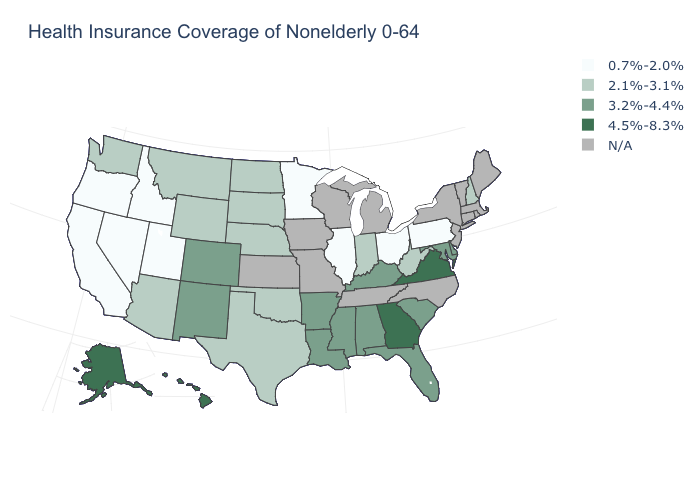Does the map have missing data?
Quick response, please. Yes. What is the value of New Hampshire?
Concise answer only. 2.1%-3.1%. What is the highest value in the USA?
Concise answer only. 4.5%-8.3%. Does Indiana have the highest value in the MidWest?
Write a very short answer. Yes. Name the states that have a value in the range 2.1%-3.1%?
Short answer required. Arizona, Indiana, Montana, Nebraska, New Hampshire, North Dakota, Oklahoma, South Dakota, Texas, Washington, West Virginia, Wyoming. Name the states that have a value in the range 4.5%-8.3%?
Give a very brief answer. Alaska, Georgia, Hawaii, Virginia. Among the states that border Colorado , does Arizona have the lowest value?
Keep it brief. No. What is the highest value in the South ?
Write a very short answer. 4.5%-8.3%. Name the states that have a value in the range 2.1%-3.1%?
Short answer required. Arizona, Indiana, Montana, Nebraska, New Hampshire, North Dakota, Oklahoma, South Dakota, Texas, Washington, West Virginia, Wyoming. Which states have the lowest value in the USA?
Keep it brief. California, Idaho, Illinois, Minnesota, Nevada, Ohio, Oregon, Pennsylvania, Utah. Name the states that have a value in the range N/A?
Give a very brief answer. Connecticut, Iowa, Kansas, Maine, Massachusetts, Michigan, Missouri, New Jersey, New York, North Carolina, Rhode Island, Tennessee, Vermont, Wisconsin. Which states have the lowest value in the South?
Be succinct. Oklahoma, Texas, West Virginia. What is the highest value in the Northeast ?
Answer briefly. 2.1%-3.1%. Does the first symbol in the legend represent the smallest category?
Keep it brief. Yes. 